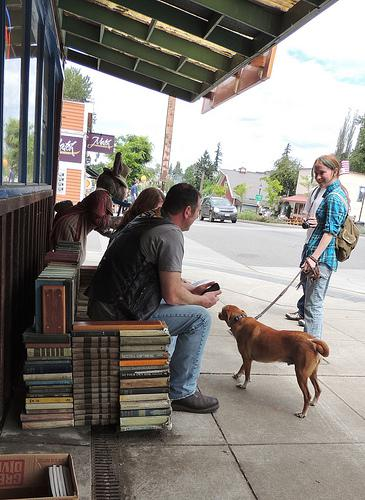Question: what is the dog doing?
Choices:
A. Sitting.
B. Sleeping.
C. Eating.
D. Standing.
Answer with the letter. Answer: D Question: what is in the distance?
Choices:
A. A bus.
B. A train.
C. A car.
D. A motorcycle.
Answer with the letter. Answer: C Question: what is in the sky?
Choices:
A. Clouds.
B. An airplane.
C. A kite.
D. The sun.
Answer with the letter. Answer: A 